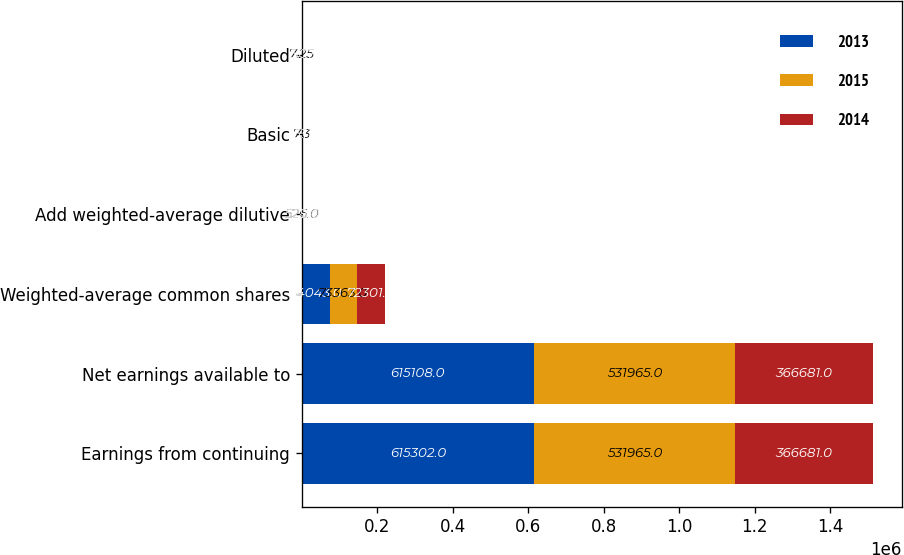<chart> <loc_0><loc_0><loc_500><loc_500><stacked_bar_chart><ecel><fcel>Earnings from continuing<fcel>Net earnings available to<fcel>Weighted-average common shares<fcel>Add weighted-average dilutive<fcel>Basic<fcel>Diluted<nl><fcel>2013<fcel>615302<fcel>615108<fcel>74043<fcel>527<fcel>8.37<fcel>8.31<nl><fcel>2015<fcel>531965<fcel>531965<fcel>73363<fcel>526<fcel>7.3<fcel>7.25<nl><fcel>2014<fcel>366681<fcel>366681<fcel>72301<fcel>528<fcel>5.11<fcel>5.07<nl></chart> 